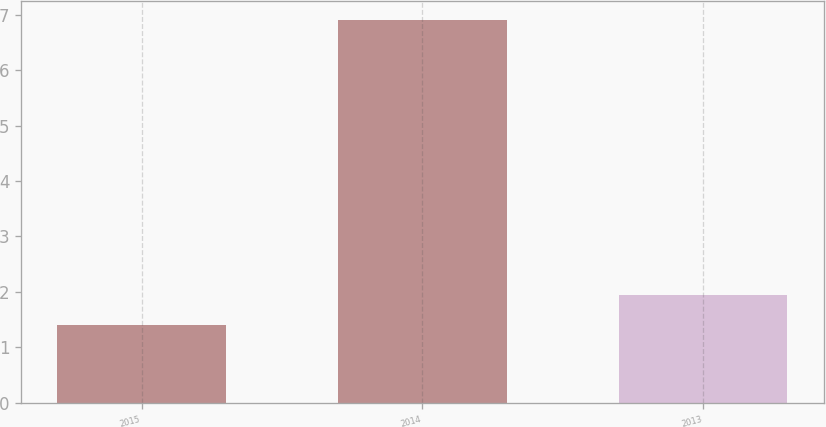Convert chart. <chart><loc_0><loc_0><loc_500><loc_500><bar_chart><fcel>2015<fcel>2014<fcel>2013<nl><fcel>1.4<fcel>6.9<fcel>1.95<nl></chart> 